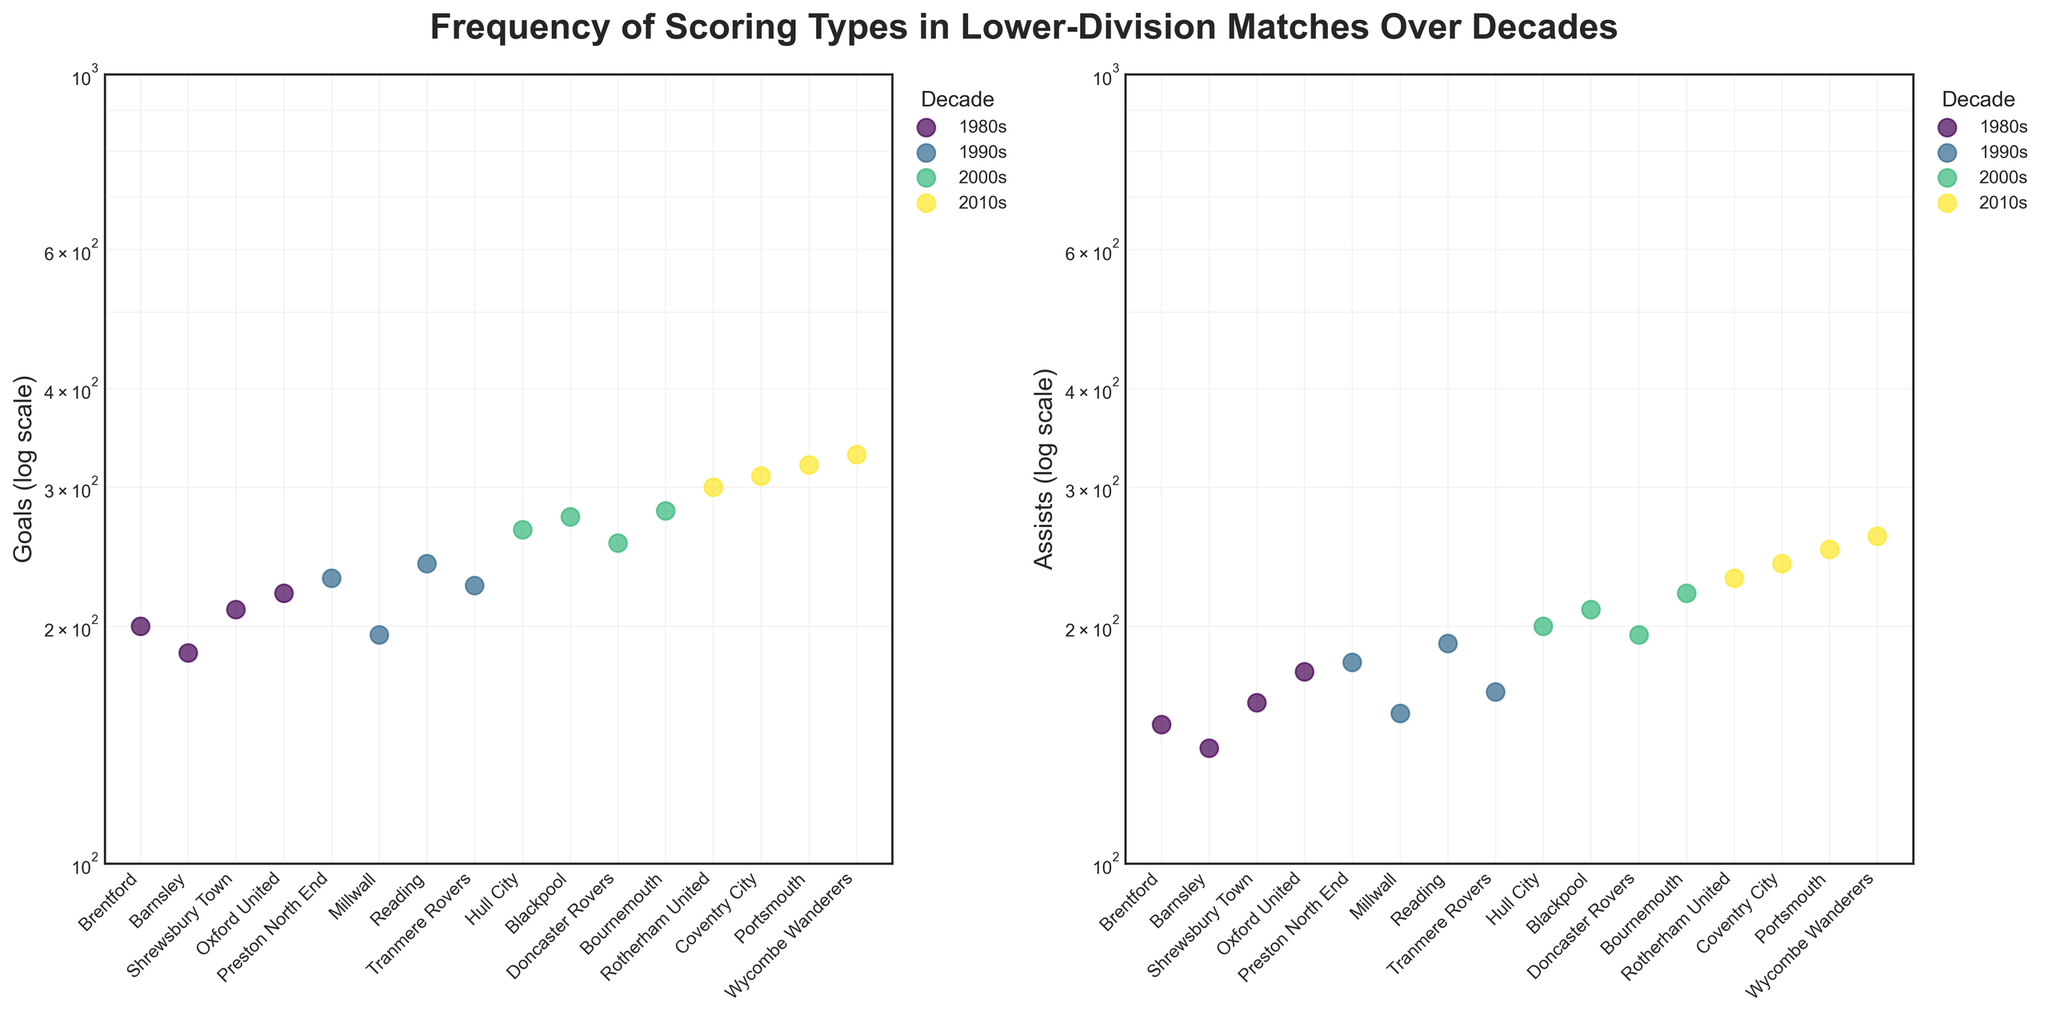Which decade had the highest number of goals scored by any team? The team with the highest number of goals in each decade must be compared. From the visual inspection of the scatter plot for goals, Wycombe Wanderers in the 2010s had the highest number of goals with 330.
Answer: 2010s How do the goals scored by Hull City in the 2000s compare to the goals scored by any team in the 1980s? Hull City in the 2000s scored 265 goals. Comparing this to the scatter plot for the 1980s (Brentford: 200, Barnsley: 185, Shrewsbury Town: 210, Oxford United: 220), Hull City’s score is higher.
Answer: Hull City scored more goals What is the difference in the number of assists between Portsmouth and Brentford? Portsmouth in the 2010s had 250 assists, while Brentford in the 1980s had 150 assists. The difference is 250 - 150 = 100.
Answer: 100 Which team had the lowest number of assists in the 1990s? Inspect the scatter plot for assists in the 1990s. Millwall scored the lowest with 155 assists.
Answer: Millwall What is the average number of goals for the teams from the 2000s? Teams and their goals in the 2000s: Hull City: 265, Blackpool: 275, Doncaster Rovers: 255, Bournemouth: 280. Average = (265 + 275 + 255 + 280) / 4 = 1075 / 4 = 268.75.
Answer: 268.75 Which decade had the most even distribution of assists across teams? Evaluate the scatter plot for the spread of assists in each decade. The evenness can be roughly assessed by the spread of data points. The 2010s appear to have a more even distribution since the range between the highest and lowest assists is smaller (230 to 260).
Answer: 2010s How does the distribution of goals change between the 1980s and 2010s? Comparing the log-scale scatter plots, the range of goals in the 1980s (185 to 220) is smaller than in the 2010s (300 to 330), indicating a broader range and higher values in the 2010s.
Answer: Broader range and higher values in the 2010s Between Tranmere Rovers and Reading in the 1990s, which team had more assists and by how much? Tranmere Rovers had 165 assists and Reading had 190 assists in the 1990s. The difference is 190 - 165 = 25.
Answer: Reading by 25 How did Bournemouth's assists in the 2000s compare to Wycombe Wanderers' assists in the 2010s? Bournemouth in the 2000s had 220 assists, whereas Wycombe Wanderers in the 2010s had 260 assists. Thus, Wycombe Wanderers had 40 more assists.
Answer: Wycombe Wanderers had 40 more Identify the team and decade with the lowest goals scored in the dataset. By examining the scatter plot, the team with the lowest goals is Barnsley in the 1980s with 185 goals.
Answer: Barnsley in the 1980s 